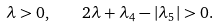Convert formula to latex. <formula><loc_0><loc_0><loc_500><loc_500>\lambda > 0 , \quad 2 \lambda + \lambda _ { 4 } - | \lambda _ { 5 } | > 0 .</formula> 